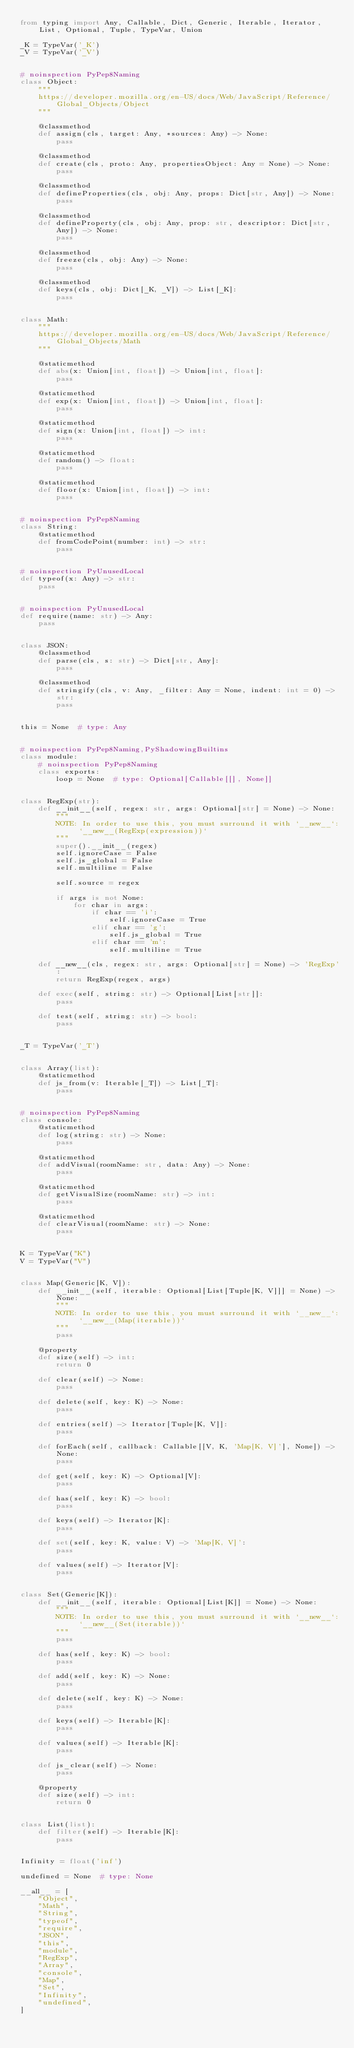Convert code to text. <code><loc_0><loc_0><loc_500><loc_500><_Python_>from typing import Any, Callable, Dict, Generic, Iterable, Iterator, List, Optional, Tuple, TypeVar, Union

_K = TypeVar('_K')
_V = TypeVar('_V')


# noinspection PyPep8Naming
class Object:
    """
    https://developer.mozilla.org/en-US/docs/Web/JavaScript/Reference/Global_Objects/Object
    """

    @classmethod
    def assign(cls, target: Any, *sources: Any) -> None:
        pass

    @classmethod
    def create(cls, proto: Any, propertiesObject: Any = None) -> None:
        pass

    @classmethod
    def defineProperties(cls, obj: Any, props: Dict[str, Any]) -> None:
        pass

    @classmethod
    def defineProperty(cls, obj: Any, prop: str, descriptor: Dict[str, Any]) -> None:
        pass

    @classmethod
    def freeze(cls, obj: Any) -> None:
        pass

    @classmethod
    def keys(cls, obj: Dict[_K, _V]) -> List[_K]:
        pass


class Math:
    """
    https://developer.mozilla.org/en-US/docs/Web/JavaScript/Reference/Global_Objects/Math
    """

    @staticmethod
    def abs(x: Union[int, float]) -> Union[int, float]:
        pass

    @staticmethod
    def exp(x: Union[int, float]) -> Union[int, float]:
        pass

    @staticmethod
    def sign(x: Union[int, float]) -> int:
        pass

    @staticmethod
    def random() -> float:
        pass

    @staticmethod
    def floor(x: Union[int, float]) -> int:
        pass


# noinspection PyPep8Naming
class String:
    @staticmethod
    def fromCodePoint(number: int) -> str:
        pass


# noinspection PyUnusedLocal
def typeof(x: Any) -> str:
    pass


# noinspection PyUnusedLocal
def require(name: str) -> Any:
    pass


class JSON:
    @classmethod
    def parse(cls, s: str) -> Dict[str, Any]:
        pass

    @classmethod
    def stringify(cls, v: Any, _filter: Any = None, indent: int = 0) -> str:
        pass


this = None  # type: Any


# noinspection PyPep8Naming,PyShadowingBuiltins
class module:
    # noinspection PyPep8Naming
    class exports:
        loop = None  # type: Optional[Callable[[], None]]


class RegExp(str):
    def __init__(self, regex: str, args: Optional[str] = None) -> None:
        """
        NOTE: In order to use this, you must surround it with `__new__`: `__new__(RegExp(expression))`
        """
        super().__init__(regex)
        self.ignoreCase = False
        self.js_global = False
        self.multiline = False

        self.source = regex

        if args is not None:
            for char in args:
                if char == 'i':
                    self.ignoreCase = True
                elif char == 'g':
                    self.js_global = True
                elif char == 'm':
                    self.multiline = True

    def __new__(cls, regex: str, args: Optional[str] = None) -> 'RegExp':
        return RegExp(regex, args)

    def exec(self, string: str) -> Optional[List[str]]:
        pass

    def test(self, string: str) -> bool:
        pass


_T = TypeVar('_T')


class Array(list):
    @staticmethod
    def js_from(v: Iterable[_T]) -> List[_T]:
        pass


# noinspection PyPep8Naming
class console:
    @staticmethod
    def log(string: str) -> None:
        pass

    @staticmethod
    def addVisual(roomName: str, data: Any) -> None:
        pass

    @staticmethod
    def getVisualSize(roomName: str) -> int:
        pass

    @staticmethod
    def clearVisual(roomName: str) -> None:
        pass


K = TypeVar("K")
V = TypeVar("V")


class Map(Generic[K, V]):
    def __init__(self, iterable: Optional[List[Tuple[K, V]]] = None) -> None:
        """
        NOTE: In order to use this, you must surround it with `__new__`: `__new__(Map(iterable))`
        """
        pass

    @property
    def size(self) -> int:
        return 0

    def clear(self) -> None:
        pass

    def delete(self, key: K) -> None:
        pass

    def entries(self) -> Iterator[Tuple[K, V]]:
        pass

    def forEach(self, callback: Callable[[V, K, 'Map[K, V]'], None]) -> None:
        pass

    def get(self, key: K) -> Optional[V]:
        pass

    def has(self, key: K) -> bool:
        pass

    def keys(self) -> Iterator[K]:
        pass

    def set(self, key: K, value: V) -> 'Map[K, V]':
        pass

    def values(self) -> Iterator[V]:
        pass


class Set(Generic[K]):
    def __init__(self, iterable: Optional[List[K]] = None) -> None:
        """
        NOTE: In order to use this, you must surround it with `__new__`: `__new__(Set(iterable))`
        """
        pass

    def has(self, key: K) -> bool:
        pass

    def add(self, key: K) -> None:
        pass

    def delete(self, key: K) -> None:
        pass

    def keys(self) -> Iterable[K]:
        pass

    def values(self) -> Iterable[K]:
        pass

    def js_clear(self) -> None:
        pass

    @property
    def size(self) -> int:
        return 0


class List(list):
    def filter(self) -> Iterable[K]:
        pass


Infinity = float('inf')

undefined = None  # type: None

__all__ = [
    "Object",
    "Math",
    "String",
    "typeof",
    "require",
    "JSON",
    "this",
    "module",
    "RegExp",
    "Array",
    "console",
    "Map",
    "Set",
    "Infinity",
    "undefined",
]
</code> 